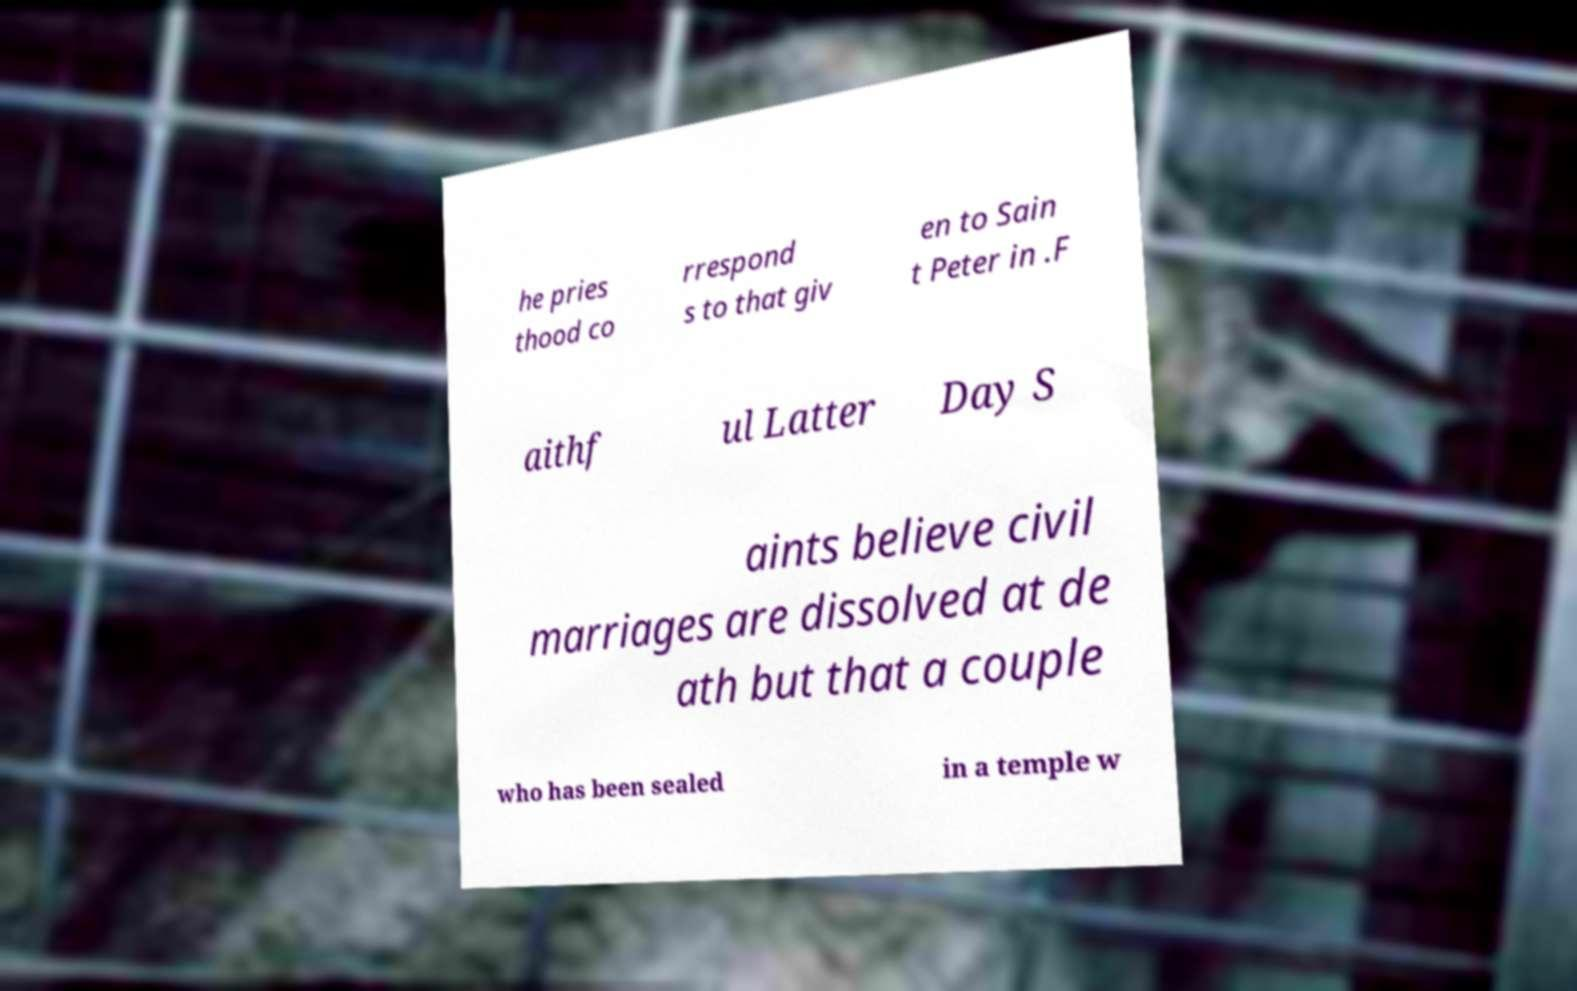Please read and relay the text visible in this image. What does it say? he pries thood co rrespond s to that giv en to Sain t Peter in .F aithf ul Latter Day S aints believe civil marriages are dissolved at de ath but that a couple who has been sealed in a temple w 